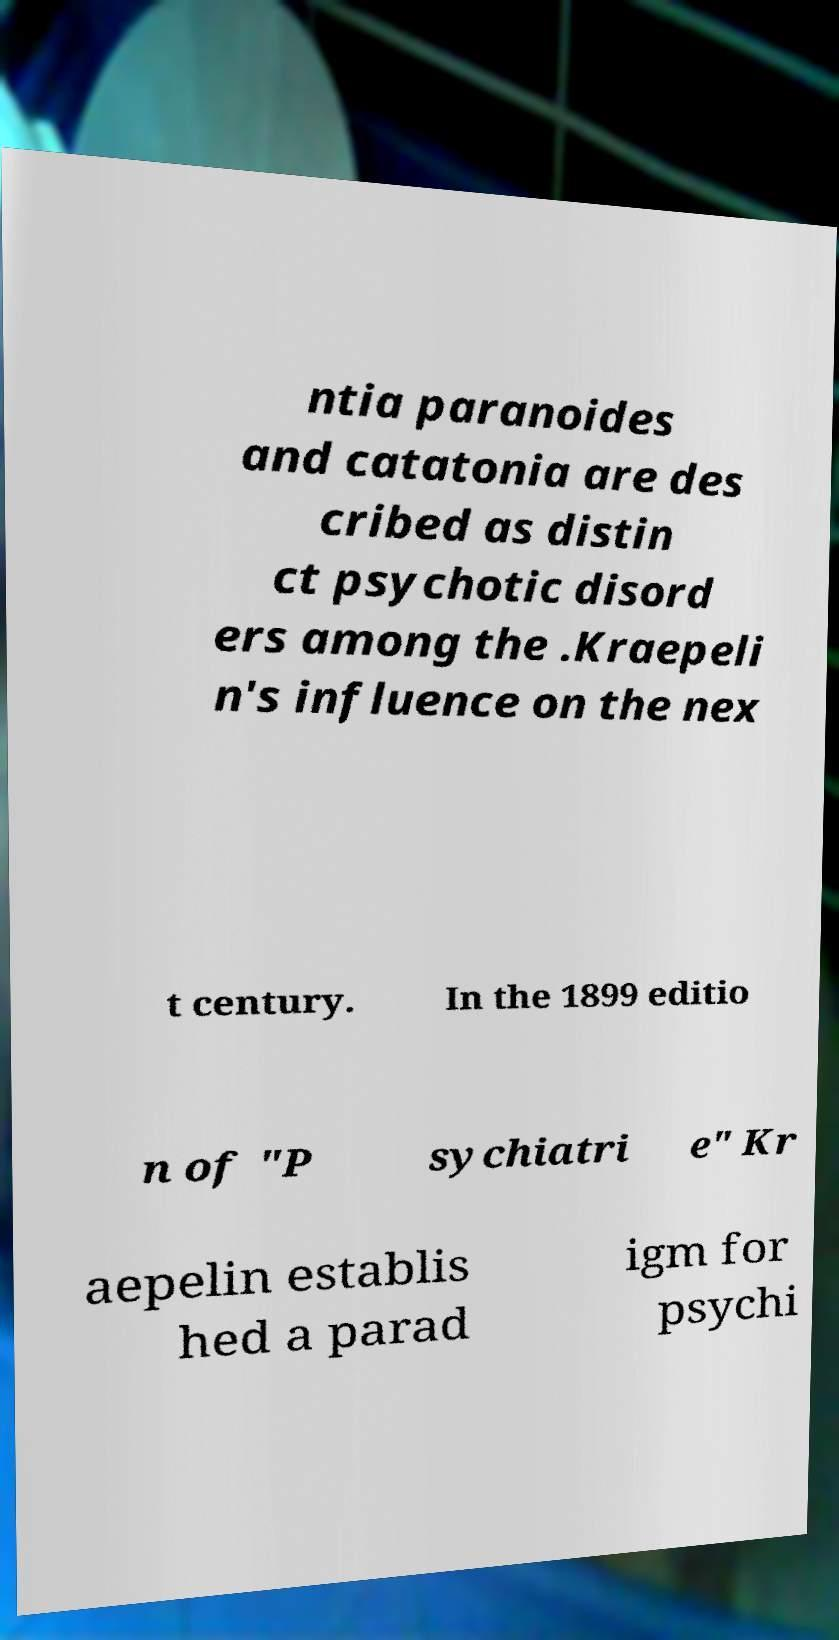Could you assist in decoding the text presented in this image and type it out clearly? ntia paranoides and catatonia are des cribed as distin ct psychotic disord ers among the .Kraepeli n's influence on the nex t century. In the 1899 editio n of "P sychiatri e" Kr aepelin establis hed a parad igm for psychi 